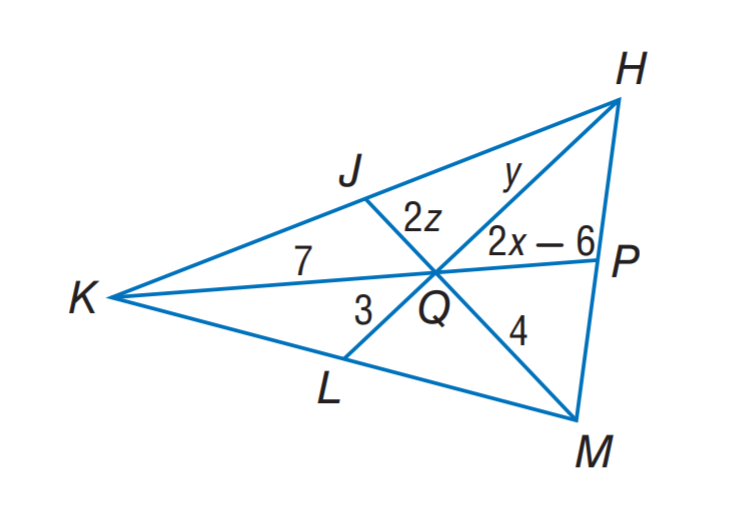Answer the mathemtical geometry problem and directly provide the correct option letter.
Question: If J, P, and L are the midpoints of K H, H M and M K, respectively. Find x.
Choices: A: 4.75 B: 5.25 C: 6 D: 7 A 